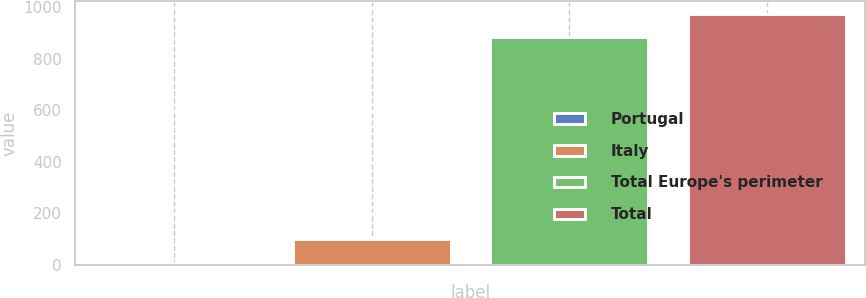Convert chart. <chart><loc_0><loc_0><loc_500><loc_500><bar_chart><fcel>Portugal<fcel>Italy<fcel>Total Europe's perimeter<fcel>Total<nl><fcel>9<fcel>99.9<fcel>884<fcel>974.9<nl></chart> 